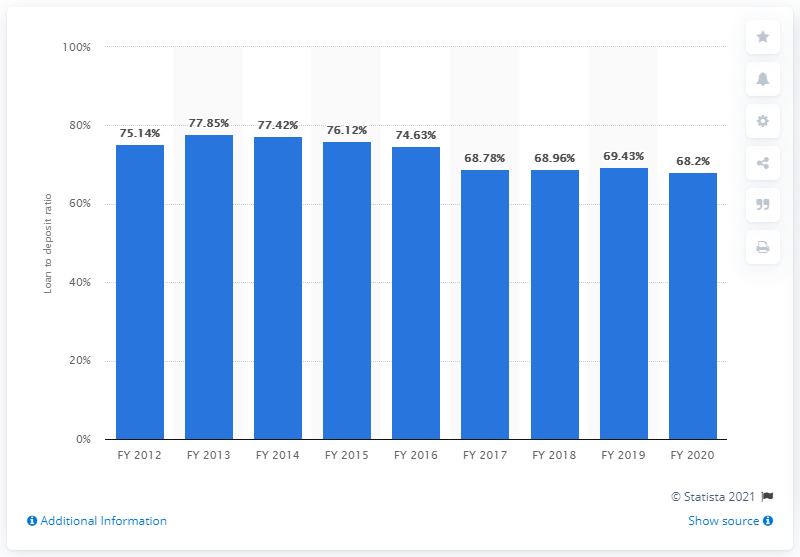Highlight a few significant elements in this photo. The loan to deposit ratio for public sector banks since 2017 was 68.2%. The loan to deposit ratio in India for financial year 2020 was 68.2%. 